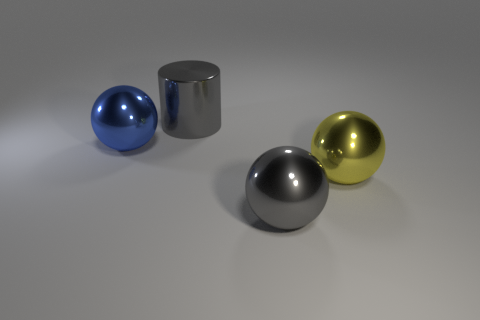Add 3 large gray spheres. How many objects exist? 7 Subtract all spheres. How many objects are left? 1 Add 2 cylinders. How many cylinders are left? 3 Add 1 gray metallic things. How many gray metallic things exist? 3 Subtract 0 green cylinders. How many objects are left? 4 Subtract all blue objects. Subtract all big green matte cylinders. How many objects are left? 3 